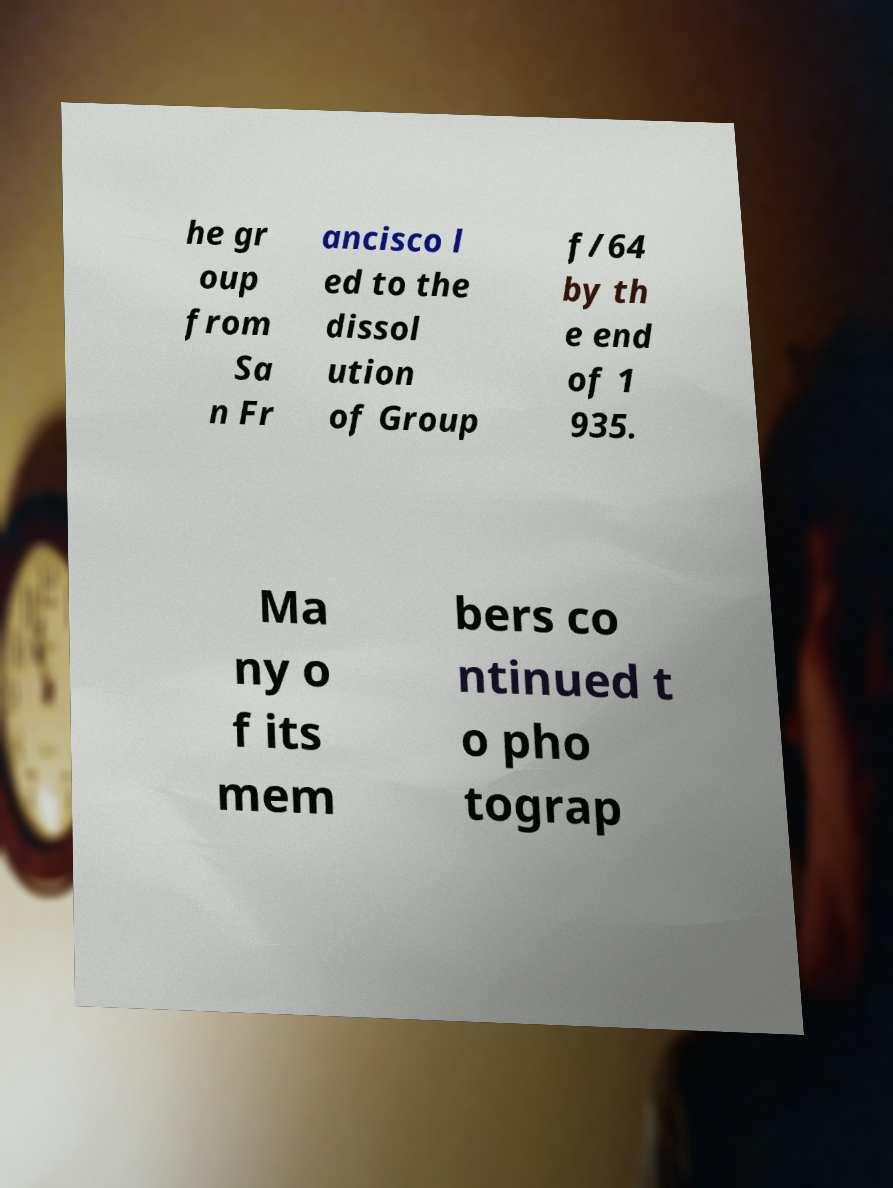Can you accurately transcribe the text from the provided image for me? he gr oup from Sa n Fr ancisco l ed to the dissol ution of Group f/64 by th e end of 1 935. Ma ny o f its mem bers co ntinued t o pho tograp 